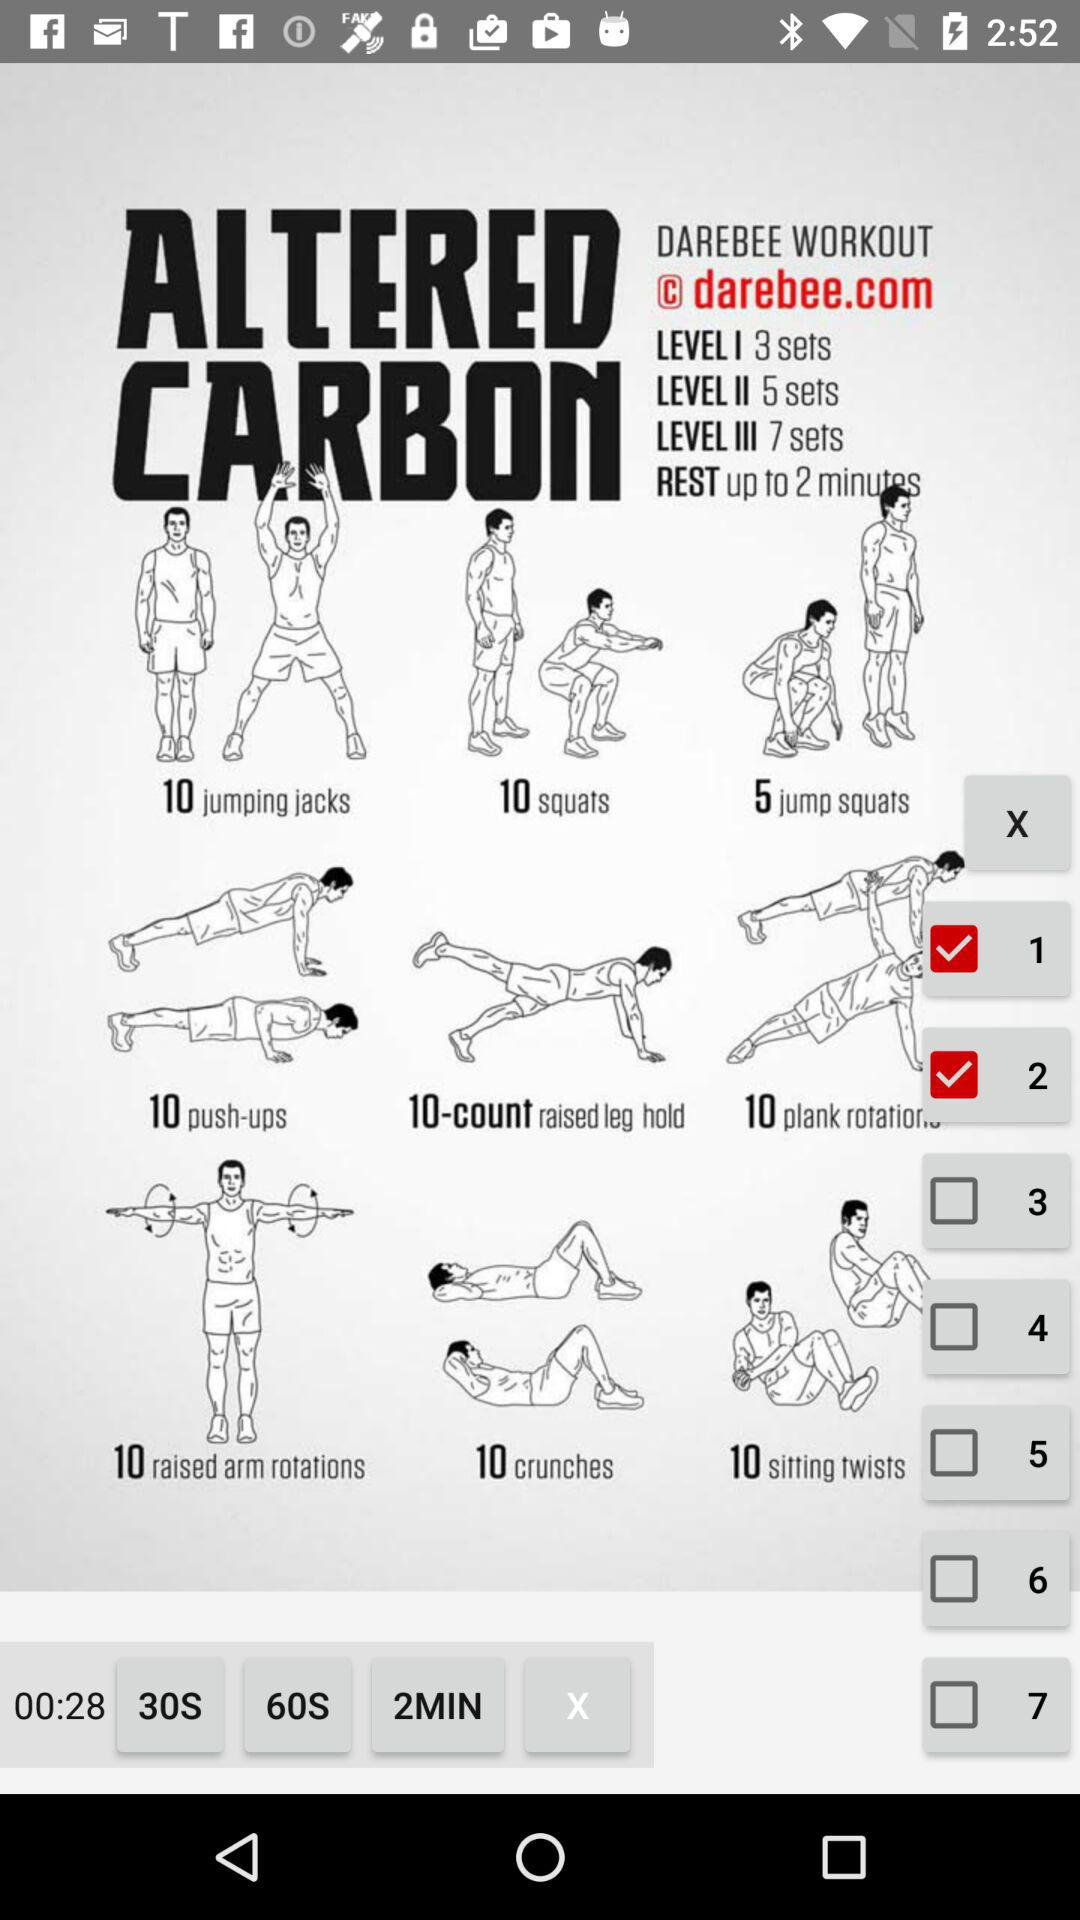How many sets are there for level 1? There are 3 sets for level 1. 